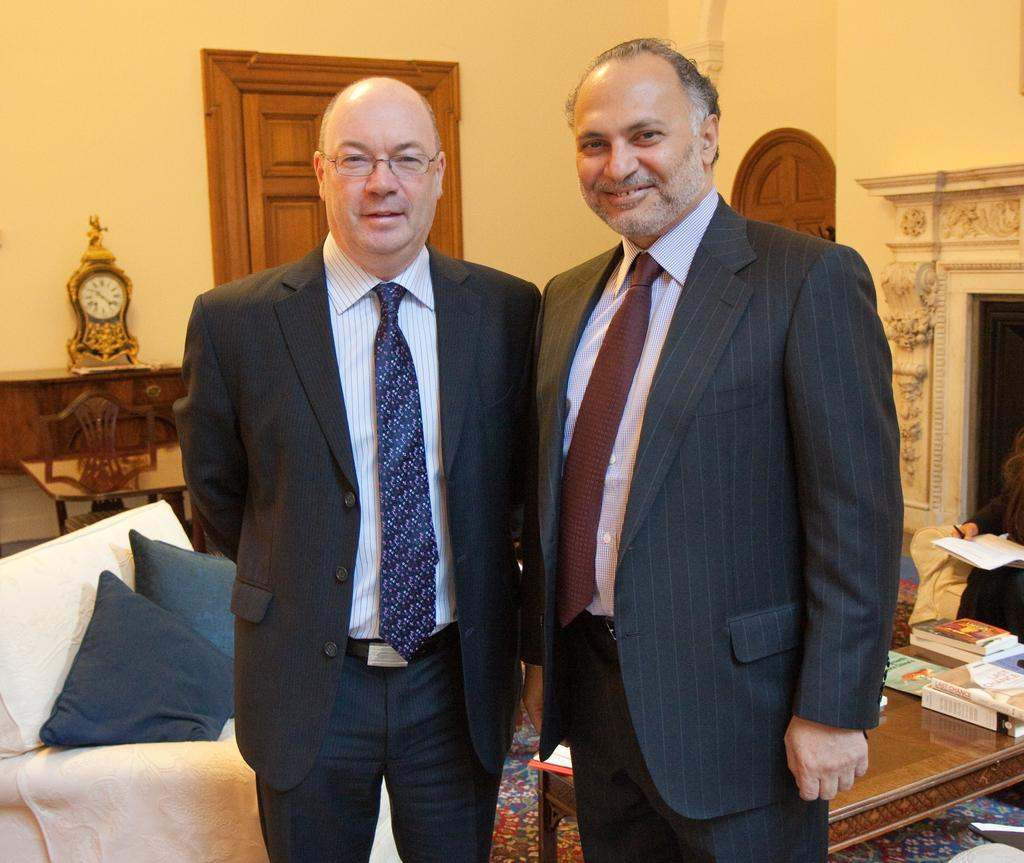What are the men in the image wearing? The men are wearing formal suits. What can be seen on the table in the background? There are books on a table in the background. What object is present on the table near the wall? There is a clock on the table near the wall. Are the men in the image feeling hot? The image does not provide information about the men's feelings or the temperature, so it cannot be determined from the image. 